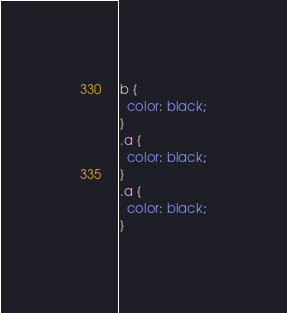<code> <loc_0><loc_0><loc_500><loc_500><_CSS_>b {
  color: black;
}
.a {
  color: black;
}
.a {
  color: black;
}
</code> 